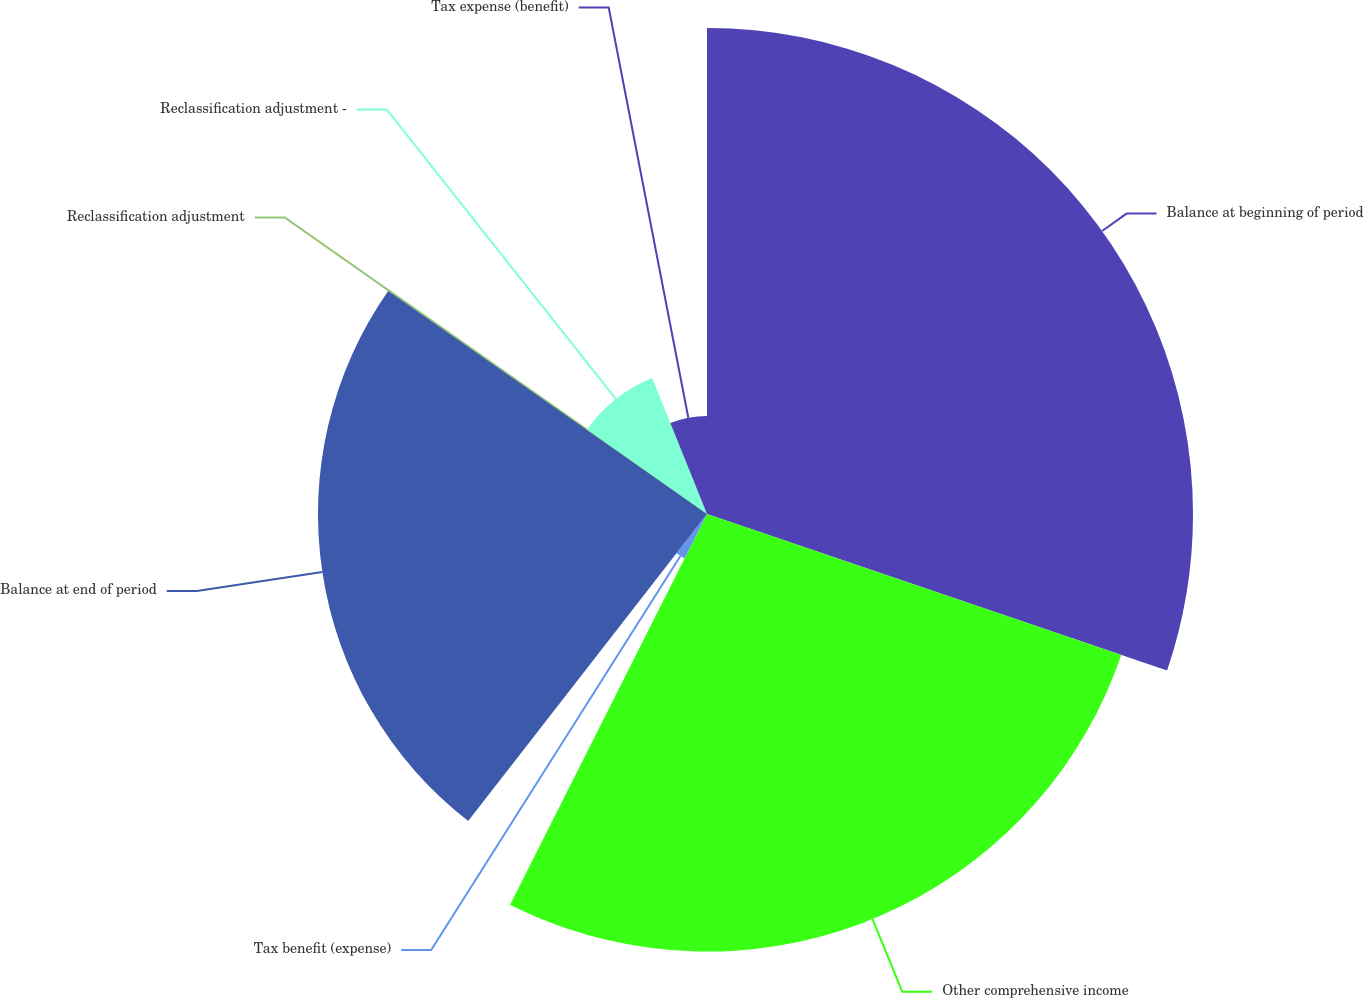Convert chart to OTSL. <chart><loc_0><loc_0><loc_500><loc_500><pie_chart><fcel>Balance at beginning of period<fcel>Other comprehensive income<fcel>Tax benefit (expense)<fcel>Balance at end of period<fcel>Reclassification adjustment<fcel>Reclassification adjustment -<fcel>Tax expense (benefit)<nl><fcel>30.22%<fcel>27.21%<fcel>3.09%<fcel>24.19%<fcel>0.07%<fcel>9.12%<fcel>6.1%<nl></chart> 